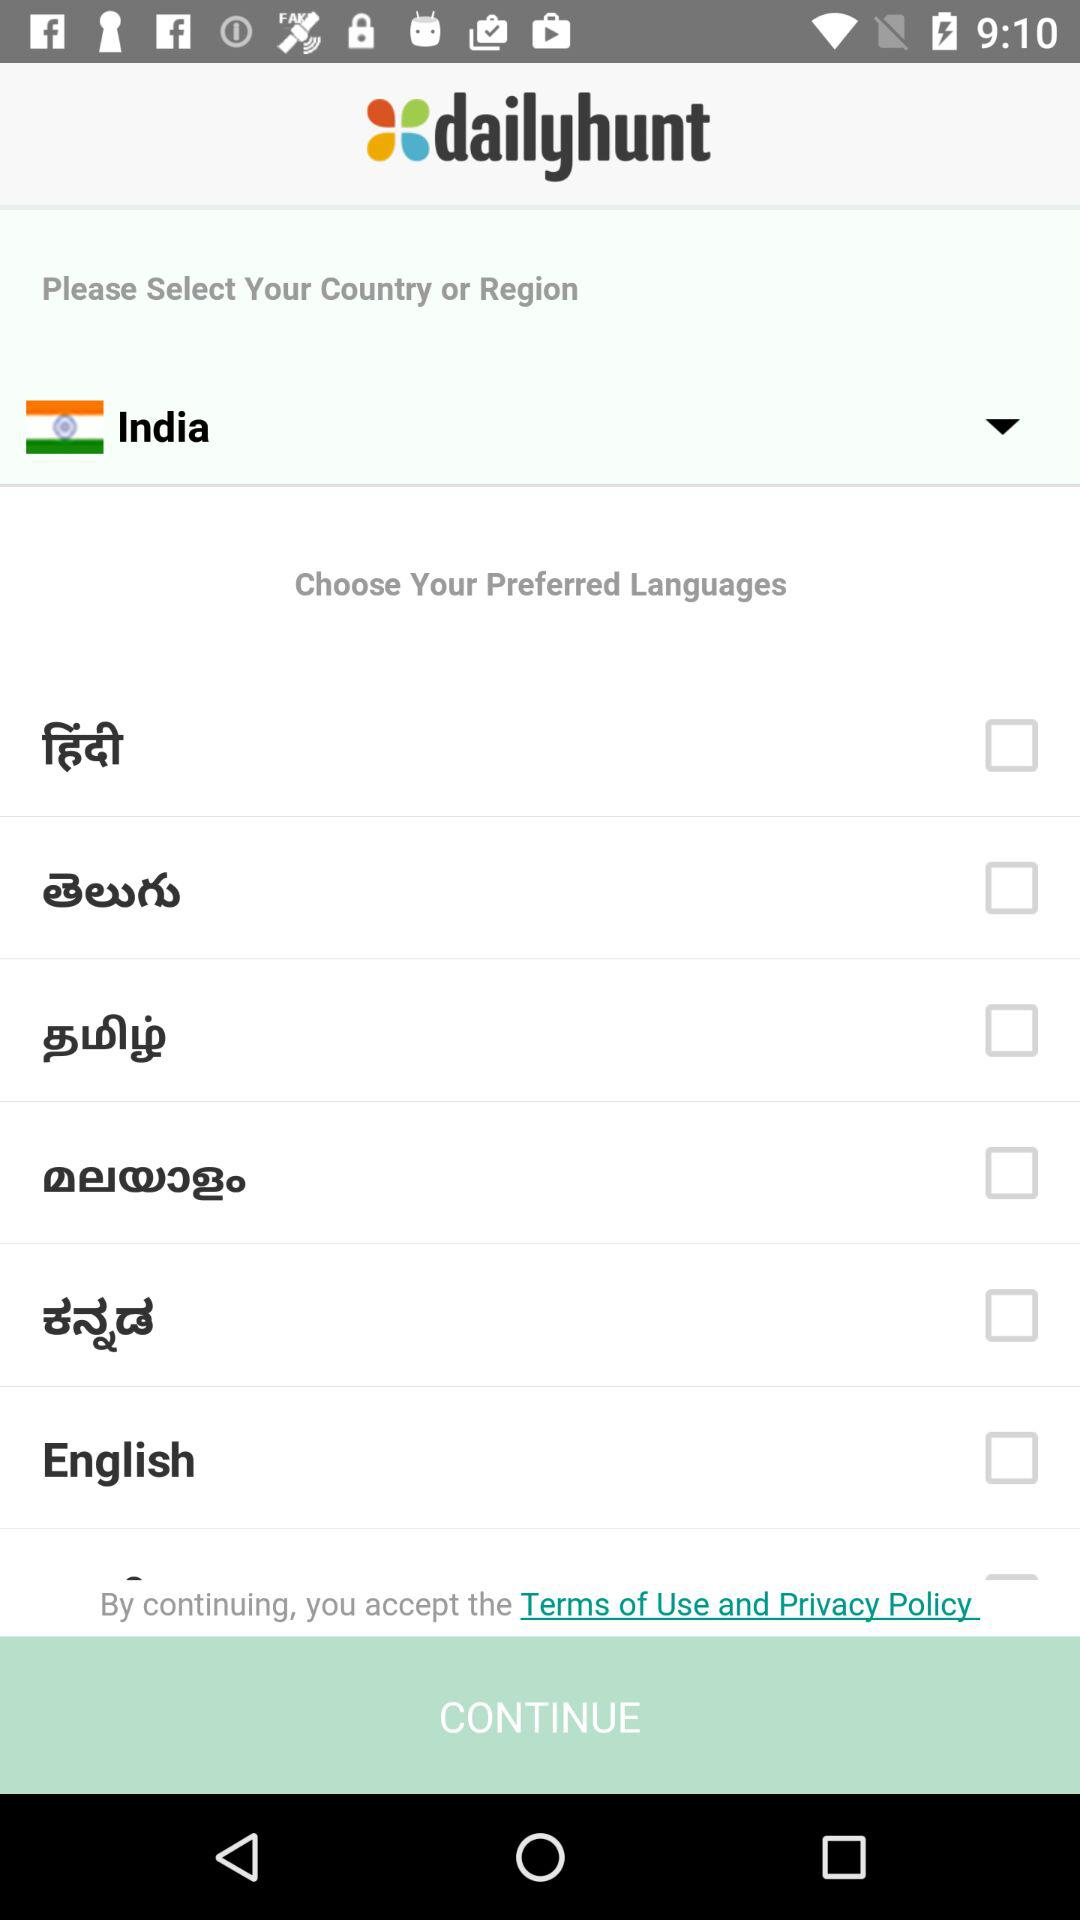Which country is selected? The selected country is India. 